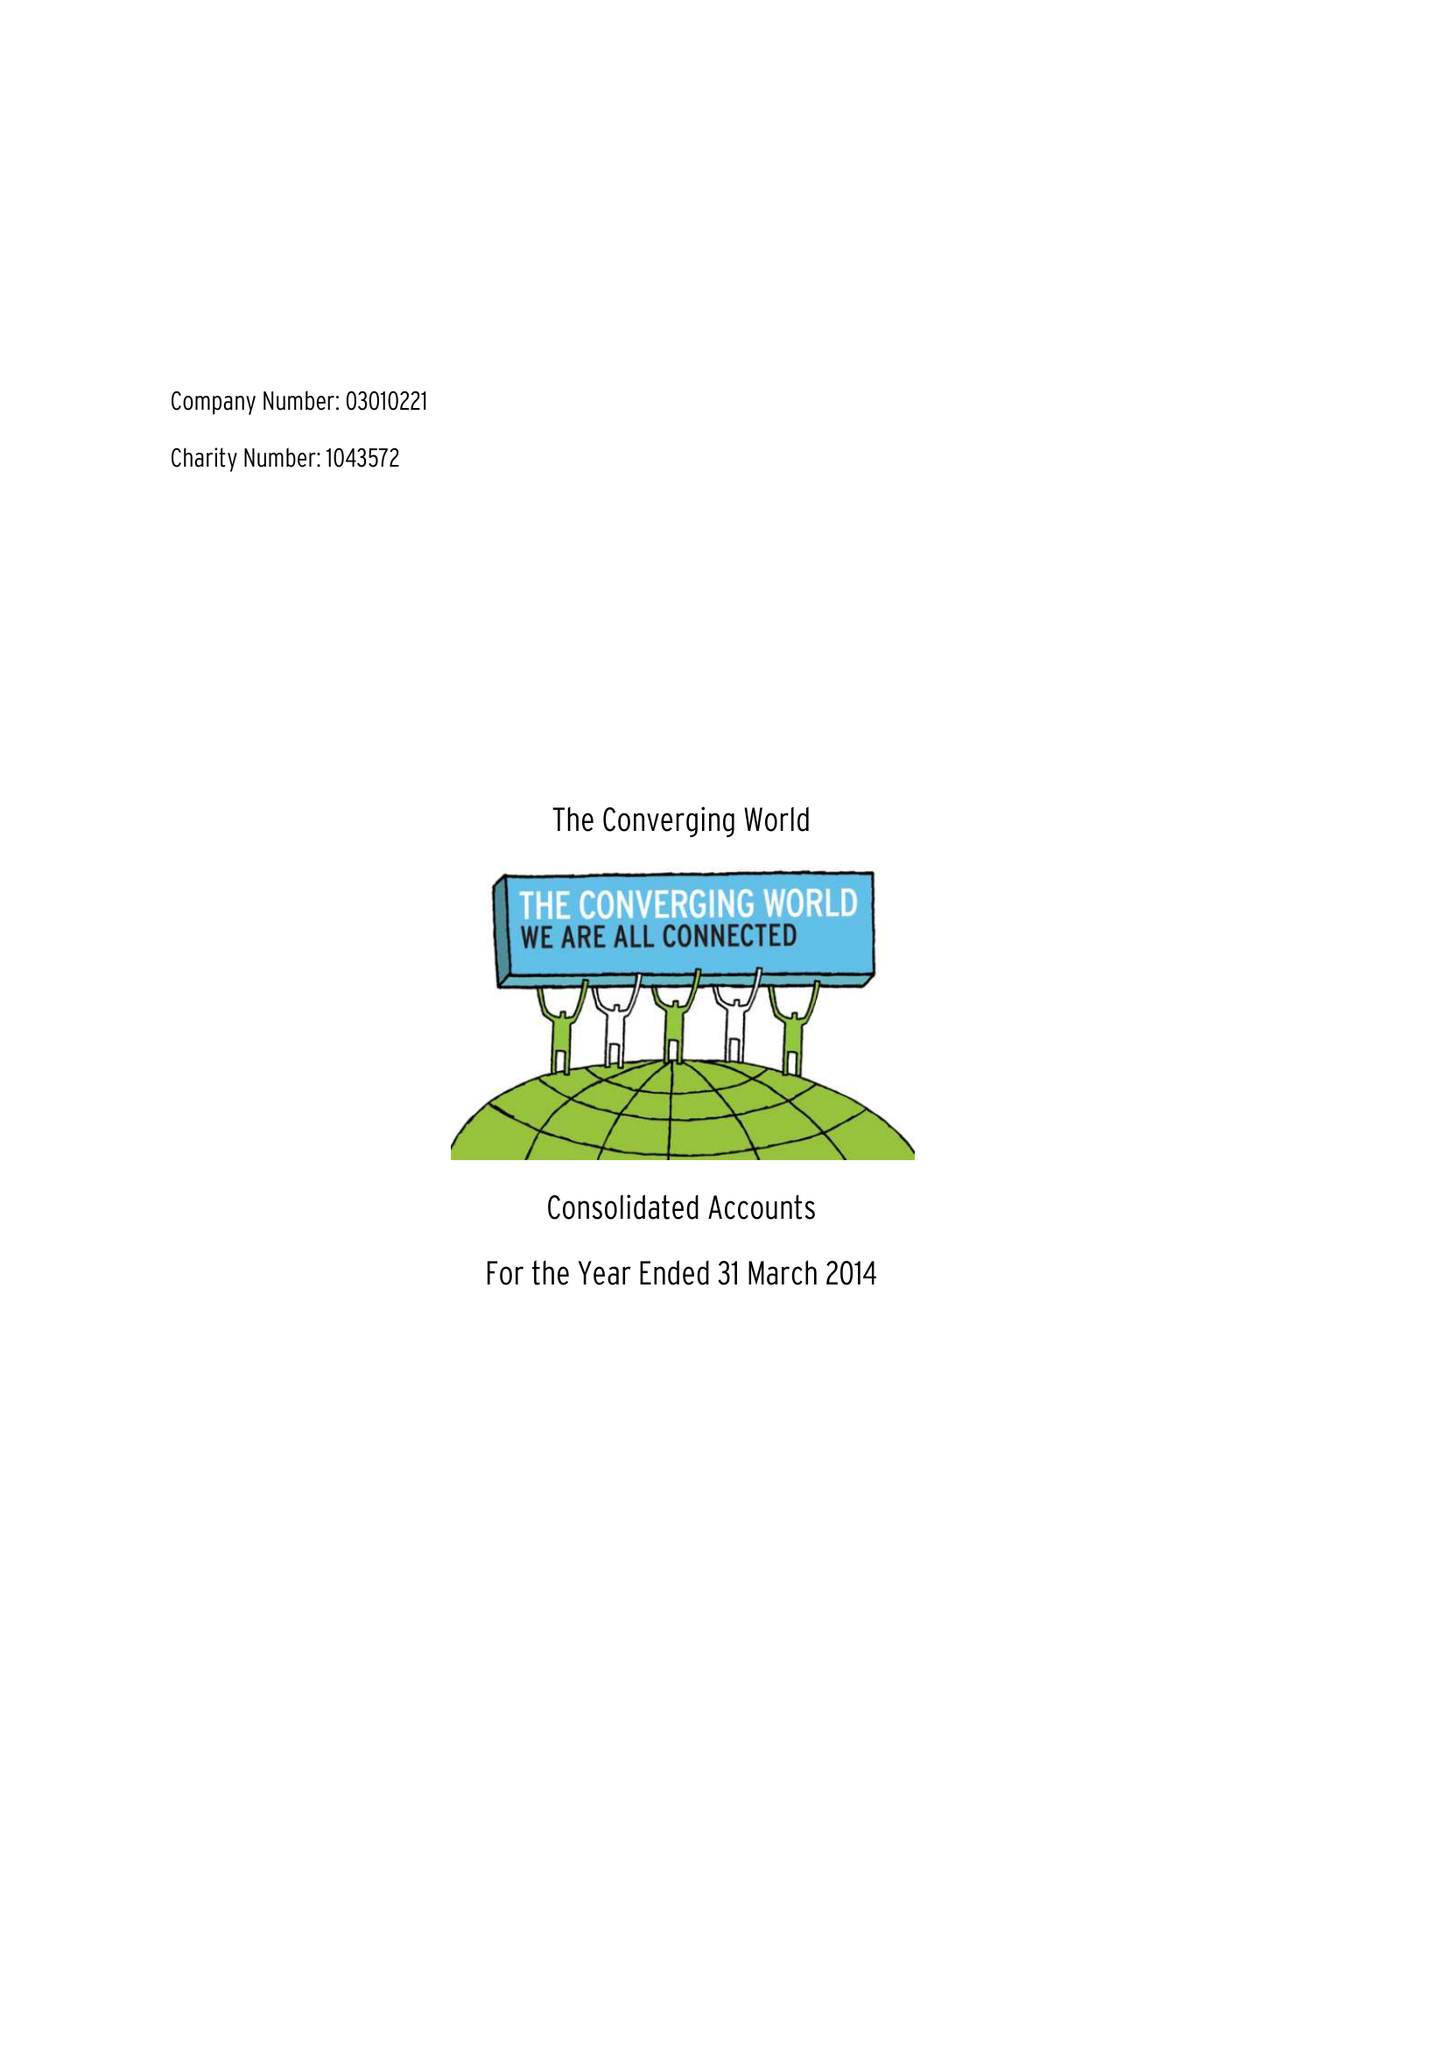What is the value for the address__street_line?
Answer the question using a single word or phrase. TUNBRIDGE ROAD 